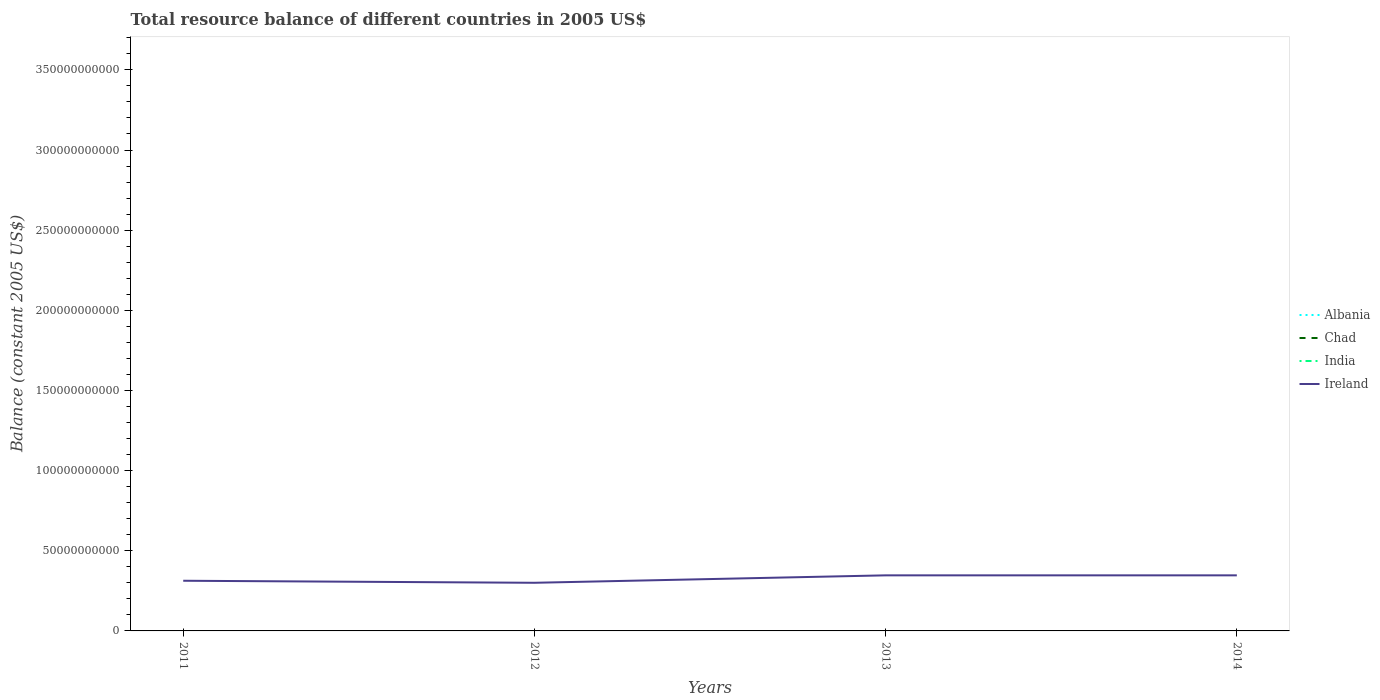Does the line corresponding to Ireland intersect with the line corresponding to Chad?
Your answer should be very brief. No. Is the number of lines equal to the number of legend labels?
Offer a very short reply. No. What is the total total resource balance in Ireland in the graph?
Provide a succinct answer. 1.27e+09. What is the difference between the highest and the second highest total resource balance in Ireland?
Provide a succinct answer. 4.65e+09. Is the total resource balance in Albania strictly greater than the total resource balance in Ireland over the years?
Offer a terse response. Yes. What is the difference between two consecutive major ticks on the Y-axis?
Give a very brief answer. 5.00e+1. Are the values on the major ticks of Y-axis written in scientific E-notation?
Your response must be concise. No. Does the graph contain grids?
Give a very brief answer. No. How many legend labels are there?
Give a very brief answer. 4. What is the title of the graph?
Offer a terse response. Total resource balance of different countries in 2005 US$. What is the label or title of the Y-axis?
Provide a succinct answer. Balance (constant 2005 US$). What is the Balance (constant 2005 US$) in Chad in 2011?
Your response must be concise. 0. What is the Balance (constant 2005 US$) of Ireland in 2011?
Your answer should be very brief. 3.13e+1. What is the Balance (constant 2005 US$) in Chad in 2012?
Ensure brevity in your answer.  0. What is the Balance (constant 2005 US$) in Ireland in 2012?
Offer a very short reply. 3.00e+1. What is the Balance (constant 2005 US$) of India in 2013?
Your response must be concise. 0. What is the Balance (constant 2005 US$) of Ireland in 2013?
Keep it short and to the point. 3.47e+1. What is the Balance (constant 2005 US$) of Albania in 2014?
Provide a succinct answer. 0. What is the Balance (constant 2005 US$) in Ireland in 2014?
Provide a short and direct response. 3.47e+1. Across all years, what is the maximum Balance (constant 2005 US$) in Ireland?
Your answer should be very brief. 3.47e+1. Across all years, what is the minimum Balance (constant 2005 US$) of Ireland?
Provide a succinct answer. 3.00e+1. What is the total Balance (constant 2005 US$) of Albania in the graph?
Provide a succinct answer. 0. What is the total Balance (constant 2005 US$) in Ireland in the graph?
Ensure brevity in your answer.  1.31e+11. What is the difference between the Balance (constant 2005 US$) of Ireland in 2011 and that in 2012?
Give a very brief answer. 1.27e+09. What is the difference between the Balance (constant 2005 US$) of Ireland in 2011 and that in 2013?
Provide a short and direct response. -3.37e+09. What is the difference between the Balance (constant 2005 US$) in Ireland in 2011 and that in 2014?
Offer a terse response. -3.37e+09. What is the difference between the Balance (constant 2005 US$) of Ireland in 2012 and that in 2013?
Keep it short and to the point. -4.64e+09. What is the difference between the Balance (constant 2005 US$) of Ireland in 2012 and that in 2014?
Provide a short and direct response. -4.65e+09. What is the difference between the Balance (constant 2005 US$) in Ireland in 2013 and that in 2014?
Offer a very short reply. -5.00e+06. What is the average Balance (constant 2005 US$) of Chad per year?
Your answer should be very brief. 0. What is the average Balance (constant 2005 US$) of Ireland per year?
Give a very brief answer. 3.27e+1. What is the ratio of the Balance (constant 2005 US$) in Ireland in 2011 to that in 2012?
Offer a very short reply. 1.04. What is the ratio of the Balance (constant 2005 US$) of Ireland in 2011 to that in 2013?
Your response must be concise. 0.9. What is the ratio of the Balance (constant 2005 US$) in Ireland in 2011 to that in 2014?
Ensure brevity in your answer.  0.9. What is the ratio of the Balance (constant 2005 US$) in Ireland in 2012 to that in 2013?
Give a very brief answer. 0.87. What is the ratio of the Balance (constant 2005 US$) of Ireland in 2012 to that in 2014?
Offer a very short reply. 0.87. What is the difference between the highest and the lowest Balance (constant 2005 US$) of Ireland?
Keep it short and to the point. 4.65e+09. 